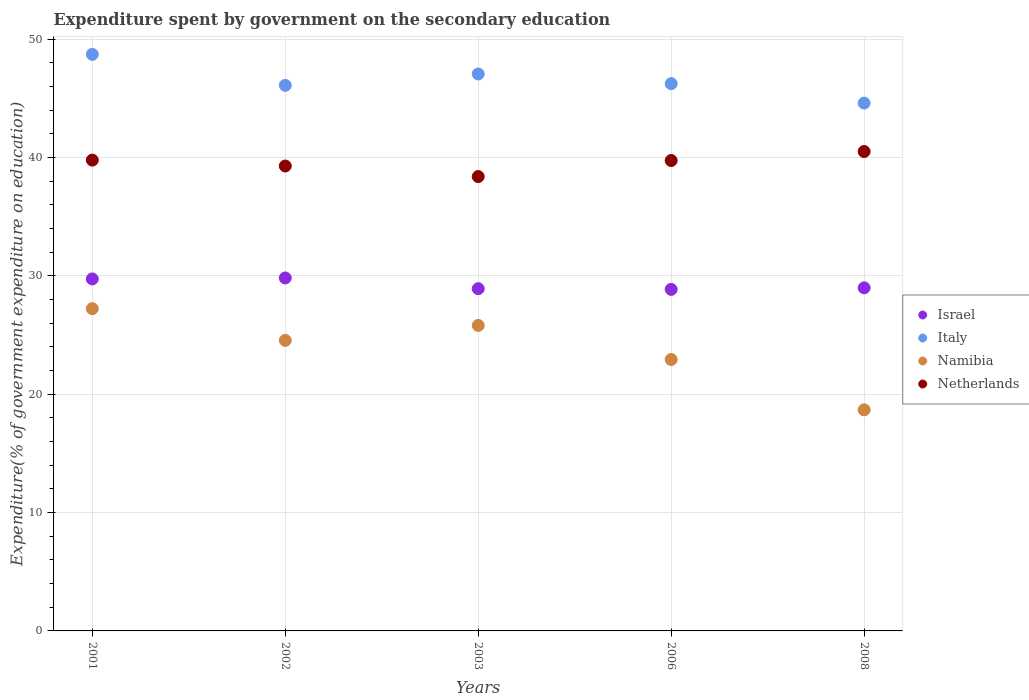How many different coloured dotlines are there?
Keep it short and to the point. 4. What is the expenditure spent by government on the secondary education in Israel in 2001?
Your answer should be compact. 29.74. Across all years, what is the maximum expenditure spent by government on the secondary education in Italy?
Your response must be concise. 48.71. Across all years, what is the minimum expenditure spent by government on the secondary education in Israel?
Provide a succinct answer. 28.85. In which year was the expenditure spent by government on the secondary education in Israel minimum?
Provide a succinct answer. 2006. What is the total expenditure spent by government on the secondary education in Namibia in the graph?
Your response must be concise. 119.19. What is the difference between the expenditure spent by government on the secondary education in Italy in 2001 and that in 2006?
Ensure brevity in your answer.  2.47. What is the difference between the expenditure spent by government on the secondary education in Israel in 2006 and the expenditure spent by government on the secondary education in Namibia in 2002?
Provide a succinct answer. 4.31. What is the average expenditure spent by government on the secondary education in Namibia per year?
Keep it short and to the point. 23.84. In the year 2008, what is the difference between the expenditure spent by government on the secondary education in Italy and expenditure spent by government on the secondary education in Namibia?
Give a very brief answer. 25.91. What is the ratio of the expenditure spent by government on the secondary education in Israel in 2002 to that in 2006?
Your response must be concise. 1.03. What is the difference between the highest and the second highest expenditure spent by government on the secondary education in Namibia?
Your response must be concise. 1.42. What is the difference between the highest and the lowest expenditure spent by government on the secondary education in Netherlands?
Keep it short and to the point. 2.12. Is it the case that in every year, the sum of the expenditure spent by government on the secondary education in Israel and expenditure spent by government on the secondary education in Netherlands  is greater than the expenditure spent by government on the secondary education in Namibia?
Your answer should be compact. Yes. How many dotlines are there?
Ensure brevity in your answer.  4. How many years are there in the graph?
Provide a succinct answer. 5. Are the values on the major ticks of Y-axis written in scientific E-notation?
Your response must be concise. No. Does the graph contain grids?
Keep it short and to the point. Yes. How many legend labels are there?
Provide a succinct answer. 4. What is the title of the graph?
Your answer should be compact. Expenditure spent by government on the secondary education. What is the label or title of the Y-axis?
Your answer should be compact. Expenditure(% of government expenditure on education). What is the Expenditure(% of government expenditure on education) in Israel in 2001?
Ensure brevity in your answer.  29.74. What is the Expenditure(% of government expenditure on education) in Italy in 2001?
Offer a very short reply. 48.71. What is the Expenditure(% of government expenditure on education) of Namibia in 2001?
Provide a succinct answer. 27.22. What is the Expenditure(% of government expenditure on education) of Netherlands in 2001?
Offer a terse response. 39.77. What is the Expenditure(% of government expenditure on education) of Israel in 2002?
Provide a succinct answer. 29.82. What is the Expenditure(% of government expenditure on education) of Italy in 2002?
Offer a terse response. 46.09. What is the Expenditure(% of government expenditure on education) of Namibia in 2002?
Your answer should be very brief. 24.55. What is the Expenditure(% of government expenditure on education) of Netherlands in 2002?
Your answer should be very brief. 39.28. What is the Expenditure(% of government expenditure on education) in Israel in 2003?
Offer a terse response. 28.91. What is the Expenditure(% of government expenditure on education) in Italy in 2003?
Provide a succinct answer. 47.05. What is the Expenditure(% of government expenditure on education) of Namibia in 2003?
Provide a succinct answer. 25.81. What is the Expenditure(% of government expenditure on education) in Netherlands in 2003?
Give a very brief answer. 38.38. What is the Expenditure(% of government expenditure on education) of Israel in 2006?
Provide a succinct answer. 28.85. What is the Expenditure(% of government expenditure on education) in Italy in 2006?
Provide a short and direct response. 46.24. What is the Expenditure(% of government expenditure on education) in Namibia in 2006?
Keep it short and to the point. 22.93. What is the Expenditure(% of government expenditure on education) of Netherlands in 2006?
Offer a terse response. 39.74. What is the Expenditure(% of government expenditure on education) of Israel in 2008?
Give a very brief answer. 28.99. What is the Expenditure(% of government expenditure on education) in Italy in 2008?
Ensure brevity in your answer.  44.59. What is the Expenditure(% of government expenditure on education) in Namibia in 2008?
Your answer should be compact. 18.68. What is the Expenditure(% of government expenditure on education) in Netherlands in 2008?
Provide a short and direct response. 40.5. Across all years, what is the maximum Expenditure(% of government expenditure on education) in Israel?
Offer a very short reply. 29.82. Across all years, what is the maximum Expenditure(% of government expenditure on education) of Italy?
Your response must be concise. 48.71. Across all years, what is the maximum Expenditure(% of government expenditure on education) of Namibia?
Provide a succinct answer. 27.22. Across all years, what is the maximum Expenditure(% of government expenditure on education) of Netherlands?
Provide a short and direct response. 40.5. Across all years, what is the minimum Expenditure(% of government expenditure on education) in Israel?
Keep it short and to the point. 28.85. Across all years, what is the minimum Expenditure(% of government expenditure on education) in Italy?
Your answer should be very brief. 44.59. Across all years, what is the minimum Expenditure(% of government expenditure on education) in Namibia?
Keep it short and to the point. 18.68. Across all years, what is the minimum Expenditure(% of government expenditure on education) of Netherlands?
Offer a terse response. 38.38. What is the total Expenditure(% of government expenditure on education) of Israel in the graph?
Offer a very short reply. 146.31. What is the total Expenditure(% of government expenditure on education) of Italy in the graph?
Your response must be concise. 232.68. What is the total Expenditure(% of government expenditure on education) of Namibia in the graph?
Offer a terse response. 119.19. What is the total Expenditure(% of government expenditure on education) of Netherlands in the graph?
Provide a succinct answer. 197.68. What is the difference between the Expenditure(% of government expenditure on education) in Israel in 2001 and that in 2002?
Provide a succinct answer. -0.08. What is the difference between the Expenditure(% of government expenditure on education) in Italy in 2001 and that in 2002?
Offer a very short reply. 2.62. What is the difference between the Expenditure(% of government expenditure on education) in Namibia in 2001 and that in 2002?
Your answer should be compact. 2.68. What is the difference between the Expenditure(% of government expenditure on education) in Netherlands in 2001 and that in 2002?
Make the answer very short. 0.5. What is the difference between the Expenditure(% of government expenditure on education) of Israel in 2001 and that in 2003?
Your answer should be very brief. 0.82. What is the difference between the Expenditure(% of government expenditure on education) of Italy in 2001 and that in 2003?
Give a very brief answer. 1.66. What is the difference between the Expenditure(% of government expenditure on education) of Namibia in 2001 and that in 2003?
Your answer should be very brief. 1.42. What is the difference between the Expenditure(% of government expenditure on education) of Netherlands in 2001 and that in 2003?
Your answer should be very brief. 1.39. What is the difference between the Expenditure(% of government expenditure on education) of Israel in 2001 and that in 2006?
Keep it short and to the point. 0.88. What is the difference between the Expenditure(% of government expenditure on education) of Italy in 2001 and that in 2006?
Make the answer very short. 2.47. What is the difference between the Expenditure(% of government expenditure on education) of Namibia in 2001 and that in 2006?
Keep it short and to the point. 4.29. What is the difference between the Expenditure(% of government expenditure on education) of Netherlands in 2001 and that in 2006?
Your answer should be compact. 0.03. What is the difference between the Expenditure(% of government expenditure on education) in Israel in 2001 and that in 2008?
Make the answer very short. 0.75. What is the difference between the Expenditure(% of government expenditure on education) in Italy in 2001 and that in 2008?
Your answer should be compact. 4.12. What is the difference between the Expenditure(% of government expenditure on education) in Namibia in 2001 and that in 2008?
Provide a short and direct response. 8.55. What is the difference between the Expenditure(% of government expenditure on education) of Netherlands in 2001 and that in 2008?
Your answer should be very brief. -0.73. What is the difference between the Expenditure(% of government expenditure on education) in Israel in 2002 and that in 2003?
Give a very brief answer. 0.91. What is the difference between the Expenditure(% of government expenditure on education) in Italy in 2002 and that in 2003?
Your answer should be very brief. -0.96. What is the difference between the Expenditure(% of government expenditure on education) in Namibia in 2002 and that in 2003?
Give a very brief answer. -1.26. What is the difference between the Expenditure(% of government expenditure on education) in Netherlands in 2002 and that in 2003?
Provide a short and direct response. 0.89. What is the difference between the Expenditure(% of government expenditure on education) of Israel in 2002 and that in 2006?
Provide a short and direct response. 0.96. What is the difference between the Expenditure(% of government expenditure on education) in Italy in 2002 and that in 2006?
Provide a succinct answer. -0.14. What is the difference between the Expenditure(% of government expenditure on education) of Namibia in 2002 and that in 2006?
Make the answer very short. 1.62. What is the difference between the Expenditure(% of government expenditure on education) in Netherlands in 2002 and that in 2006?
Your answer should be compact. -0.46. What is the difference between the Expenditure(% of government expenditure on education) of Israel in 2002 and that in 2008?
Offer a very short reply. 0.83. What is the difference between the Expenditure(% of government expenditure on education) in Italy in 2002 and that in 2008?
Make the answer very short. 1.5. What is the difference between the Expenditure(% of government expenditure on education) of Namibia in 2002 and that in 2008?
Make the answer very short. 5.87. What is the difference between the Expenditure(% of government expenditure on education) of Netherlands in 2002 and that in 2008?
Give a very brief answer. -1.22. What is the difference between the Expenditure(% of government expenditure on education) in Israel in 2003 and that in 2006?
Your answer should be compact. 0.06. What is the difference between the Expenditure(% of government expenditure on education) of Italy in 2003 and that in 2006?
Make the answer very short. 0.82. What is the difference between the Expenditure(% of government expenditure on education) in Namibia in 2003 and that in 2006?
Keep it short and to the point. 2.88. What is the difference between the Expenditure(% of government expenditure on education) of Netherlands in 2003 and that in 2006?
Keep it short and to the point. -1.36. What is the difference between the Expenditure(% of government expenditure on education) of Israel in 2003 and that in 2008?
Your response must be concise. -0.07. What is the difference between the Expenditure(% of government expenditure on education) of Italy in 2003 and that in 2008?
Make the answer very short. 2.46. What is the difference between the Expenditure(% of government expenditure on education) in Namibia in 2003 and that in 2008?
Provide a short and direct response. 7.13. What is the difference between the Expenditure(% of government expenditure on education) in Netherlands in 2003 and that in 2008?
Keep it short and to the point. -2.12. What is the difference between the Expenditure(% of government expenditure on education) of Israel in 2006 and that in 2008?
Provide a succinct answer. -0.13. What is the difference between the Expenditure(% of government expenditure on education) of Italy in 2006 and that in 2008?
Your answer should be compact. 1.64. What is the difference between the Expenditure(% of government expenditure on education) of Namibia in 2006 and that in 2008?
Ensure brevity in your answer.  4.25. What is the difference between the Expenditure(% of government expenditure on education) in Netherlands in 2006 and that in 2008?
Provide a short and direct response. -0.76. What is the difference between the Expenditure(% of government expenditure on education) of Israel in 2001 and the Expenditure(% of government expenditure on education) of Italy in 2002?
Keep it short and to the point. -16.35. What is the difference between the Expenditure(% of government expenditure on education) in Israel in 2001 and the Expenditure(% of government expenditure on education) in Namibia in 2002?
Your answer should be very brief. 5.19. What is the difference between the Expenditure(% of government expenditure on education) in Israel in 2001 and the Expenditure(% of government expenditure on education) in Netherlands in 2002?
Make the answer very short. -9.54. What is the difference between the Expenditure(% of government expenditure on education) of Italy in 2001 and the Expenditure(% of government expenditure on education) of Namibia in 2002?
Offer a very short reply. 24.16. What is the difference between the Expenditure(% of government expenditure on education) of Italy in 2001 and the Expenditure(% of government expenditure on education) of Netherlands in 2002?
Provide a short and direct response. 9.43. What is the difference between the Expenditure(% of government expenditure on education) of Namibia in 2001 and the Expenditure(% of government expenditure on education) of Netherlands in 2002?
Offer a very short reply. -12.05. What is the difference between the Expenditure(% of government expenditure on education) in Israel in 2001 and the Expenditure(% of government expenditure on education) in Italy in 2003?
Ensure brevity in your answer.  -17.32. What is the difference between the Expenditure(% of government expenditure on education) of Israel in 2001 and the Expenditure(% of government expenditure on education) of Namibia in 2003?
Provide a succinct answer. 3.93. What is the difference between the Expenditure(% of government expenditure on education) of Israel in 2001 and the Expenditure(% of government expenditure on education) of Netherlands in 2003?
Your answer should be very brief. -8.65. What is the difference between the Expenditure(% of government expenditure on education) of Italy in 2001 and the Expenditure(% of government expenditure on education) of Namibia in 2003?
Give a very brief answer. 22.9. What is the difference between the Expenditure(% of government expenditure on education) of Italy in 2001 and the Expenditure(% of government expenditure on education) of Netherlands in 2003?
Make the answer very short. 10.33. What is the difference between the Expenditure(% of government expenditure on education) of Namibia in 2001 and the Expenditure(% of government expenditure on education) of Netherlands in 2003?
Provide a succinct answer. -11.16. What is the difference between the Expenditure(% of government expenditure on education) of Israel in 2001 and the Expenditure(% of government expenditure on education) of Italy in 2006?
Offer a terse response. -16.5. What is the difference between the Expenditure(% of government expenditure on education) in Israel in 2001 and the Expenditure(% of government expenditure on education) in Namibia in 2006?
Your answer should be compact. 6.81. What is the difference between the Expenditure(% of government expenditure on education) in Israel in 2001 and the Expenditure(% of government expenditure on education) in Netherlands in 2006?
Keep it short and to the point. -10. What is the difference between the Expenditure(% of government expenditure on education) in Italy in 2001 and the Expenditure(% of government expenditure on education) in Namibia in 2006?
Your response must be concise. 25.78. What is the difference between the Expenditure(% of government expenditure on education) in Italy in 2001 and the Expenditure(% of government expenditure on education) in Netherlands in 2006?
Your answer should be very brief. 8.97. What is the difference between the Expenditure(% of government expenditure on education) of Namibia in 2001 and the Expenditure(% of government expenditure on education) of Netherlands in 2006?
Keep it short and to the point. -12.52. What is the difference between the Expenditure(% of government expenditure on education) of Israel in 2001 and the Expenditure(% of government expenditure on education) of Italy in 2008?
Provide a short and direct response. -14.86. What is the difference between the Expenditure(% of government expenditure on education) in Israel in 2001 and the Expenditure(% of government expenditure on education) in Namibia in 2008?
Offer a very short reply. 11.06. What is the difference between the Expenditure(% of government expenditure on education) in Israel in 2001 and the Expenditure(% of government expenditure on education) in Netherlands in 2008?
Your response must be concise. -10.76. What is the difference between the Expenditure(% of government expenditure on education) of Italy in 2001 and the Expenditure(% of government expenditure on education) of Namibia in 2008?
Your response must be concise. 30.03. What is the difference between the Expenditure(% of government expenditure on education) of Italy in 2001 and the Expenditure(% of government expenditure on education) of Netherlands in 2008?
Give a very brief answer. 8.21. What is the difference between the Expenditure(% of government expenditure on education) in Namibia in 2001 and the Expenditure(% of government expenditure on education) in Netherlands in 2008?
Provide a short and direct response. -13.28. What is the difference between the Expenditure(% of government expenditure on education) of Israel in 2002 and the Expenditure(% of government expenditure on education) of Italy in 2003?
Keep it short and to the point. -17.23. What is the difference between the Expenditure(% of government expenditure on education) in Israel in 2002 and the Expenditure(% of government expenditure on education) in Namibia in 2003?
Your answer should be compact. 4.01. What is the difference between the Expenditure(% of government expenditure on education) of Israel in 2002 and the Expenditure(% of government expenditure on education) of Netherlands in 2003?
Give a very brief answer. -8.57. What is the difference between the Expenditure(% of government expenditure on education) in Italy in 2002 and the Expenditure(% of government expenditure on education) in Namibia in 2003?
Provide a succinct answer. 20.28. What is the difference between the Expenditure(% of government expenditure on education) in Italy in 2002 and the Expenditure(% of government expenditure on education) in Netherlands in 2003?
Provide a short and direct response. 7.71. What is the difference between the Expenditure(% of government expenditure on education) in Namibia in 2002 and the Expenditure(% of government expenditure on education) in Netherlands in 2003?
Your answer should be compact. -13.84. What is the difference between the Expenditure(% of government expenditure on education) in Israel in 2002 and the Expenditure(% of government expenditure on education) in Italy in 2006?
Your answer should be compact. -16.42. What is the difference between the Expenditure(% of government expenditure on education) in Israel in 2002 and the Expenditure(% of government expenditure on education) in Namibia in 2006?
Provide a succinct answer. 6.89. What is the difference between the Expenditure(% of government expenditure on education) of Israel in 2002 and the Expenditure(% of government expenditure on education) of Netherlands in 2006?
Provide a succinct answer. -9.92. What is the difference between the Expenditure(% of government expenditure on education) in Italy in 2002 and the Expenditure(% of government expenditure on education) in Namibia in 2006?
Keep it short and to the point. 23.16. What is the difference between the Expenditure(% of government expenditure on education) in Italy in 2002 and the Expenditure(% of government expenditure on education) in Netherlands in 2006?
Give a very brief answer. 6.35. What is the difference between the Expenditure(% of government expenditure on education) of Namibia in 2002 and the Expenditure(% of government expenditure on education) of Netherlands in 2006?
Your response must be concise. -15.19. What is the difference between the Expenditure(% of government expenditure on education) of Israel in 2002 and the Expenditure(% of government expenditure on education) of Italy in 2008?
Offer a very short reply. -14.77. What is the difference between the Expenditure(% of government expenditure on education) in Israel in 2002 and the Expenditure(% of government expenditure on education) in Namibia in 2008?
Keep it short and to the point. 11.14. What is the difference between the Expenditure(% of government expenditure on education) of Israel in 2002 and the Expenditure(% of government expenditure on education) of Netherlands in 2008?
Your answer should be very brief. -10.68. What is the difference between the Expenditure(% of government expenditure on education) in Italy in 2002 and the Expenditure(% of government expenditure on education) in Namibia in 2008?
Keep it short and to the point. 27.41. What is the difference between the Expenditure(% of government expenditure on education) of Italy in 2002 and the Expenditure(% of government expenditure on education) of Netherlands in 2008?
Make the answer very short. 5.59. What is the difference between the Expenditure(% of government expenditure on education) of Namibia in 2002 and the Expenditure(% of government expenditure on education) of Netherlands in 2008?
Your answer should be very brief. -15.95. What is the difference between the Expenditure(% of government expenditure on education) of Israel in 2003 and the Expenditure(% of government expenditure on education) of Italy in 2006?
Make the answer very short. -17.32. What is the difference between the Expenditure(% of government expenditure on education) in Israel in 2003 and the Expenditure(% of government expenditure on education) in Namibia in 2006?
Your answer should be compact. 5.98. What is the difference between the Expenditure(% of government expenditure on education) in Israel in 2003 and the Expenditure(% of government expenditure on education) in Netherlands in 2006?
Keep it short and to the point. -10.83. What is the difference between the Expenditure(% of government expenditure on education) in Italy in 2003 and the Expenditure(% of government expenditure on education) in Namibia in 2006?
Ensure brevity in your answer.  24.12. What is the difference between the Expenditure(% of government expenditure on education) in Italy in 2003 and the Expenditure(% of government expenditure on education) in Netherlands in 2006?
Ensure brevity in your answer.  7.31. What is the difference between the Expenditure(% of government expenditure on education) in Namibia in 2003 and the Expenditure(% of government expenditure on education) in Netherlands in 2006?
Ensure brevity in your answer.  -13.93. What is the difference between the Expenditure(% of government expenditure on education) of Israel in 2003 and the Expenditure(% of government expenditure on education) of Italy in 2008?
Offer a very short reply. -15.68. What is the difference between the Expenditure(% of government expenditure on education) of Israel in 2003 and the Expenditure(% of government expenditure on education) of Namibia in 2008?
Offer a very short reply. 10.23. What is the difference between the Expenditure(% of government expenditure on education) of Israel in 2003 and the Expenditure(% of government expenditure on education) of Netherlands in 2008?
Your answer should be compact. -11.59. What is the difference between the Expenditure(% of government expenditure on education) in Italy in 2003 and the Expenditure(% of government expenditure on education) in Namibia in 2008?
Offer a terse response. 28.37. What is the difference between the Expenditure(% of government expenditure on education) of Italy in 2003 and the Expenditure(% of government expenditure on education) of Netherlands in 2008?
Ensure brevity in your answer.  6.55. What is the difference between the Expenditure(% of government expenditure on education) of Namibia in 2003 and the Expenditure(% of government expenditure on education) of Netherlands in 2008?
Ensure brevity in your answer.  -14.69. What is the difference between the Expenditure(% of government expenditure on education) in Israel in 2006 and the Expenditure(% of government expenditure on education) in Italy in 2008?
Ensure brevity in your answer.  -15.74. What is the difference between the Expenditure(% of government expenditure on education) in Israel in 2006 and the Expenditure(% of government expenditure on education) in Namibia in 2008?
Your response must be concise. 10.18. What is the difference between the Expenditure(% of government expenditure on education) of Israel in 2006 and the Expenditure(% of government expenditure on education) of Netherlands in 2008?
Offer a terse response. -11.65. What is the difference between the Expenditure(% of government expenditure on education) of Italy in 2006 and the Expenditure(% of government expenditure on education) of Namibia in 2008?
Offer a terse response. 27.56. What is the difference between the Expenditure(% of government expenditure on education) in Italy in 2006 and the Expenditure(% of government expenditure on education) in Netherlands in 2008?
Provide a short and direct response. 5.74. What is the difference between the Expenditure(% of government expenditure on education) in Namibia in 2006 and the Expenditure(% of government expenditure on education) in Netherlands in 2008?
Keep it short and to the point. -17.57. What is the average Expenditure(% of government expenditure on education) in Israel per year?
Keep it short and to the point. 29.26. What is the average Expenditure(% of government expenditure on education) of Italy per year?
Offer a very short reply. 46.54. What is the average Expenditure(% of government expenditure on education) in Namibia per year?
Provide a succinct answer. 23.84. What is the average Expenditure(% of government expenditure on education) of Netherlands per year?
Your response must be concise. 39.53. In the year 2001, what is the difference between the Expenditure(% of government expenditure on education) of Israel and Expenditure(% of government expenditure on education) of Italy?
Offer a very short reply. -18.97. In the year 2001, what is the difference between the Expenditure(% of government expenditure on education) of Israel and Expenditure(% of government expenditure on education) of Namibia?
Your answer should be compact. 2.51. In the year 2001, what is the difference between the Expenditure(% of government expenditure on education) of Israel and Expenditure(% of government expenditure on education) of Netherlands?
Provide a succinct answer. -10.04. In the year 2001, what is the difference between the Expenditure(% of government expenditure on education) in Italy and Expenditure(% of government expenditure on education) in Namibia?
Provide a succinct answer. 21.49. In the year 2001, what is the difference between the Expenditure(% of government expenditure on education) of Italy and Expenditure(% of government expenditure on education) of Netherlands?
Offer a terse response. 8.94. In the year 2001, what is the difference between the Expenditure(% of government expenditure on education) of Namibia and Expenditure(% of government expenditure on education) of Netherlands?
Provide a succinct answer. -12.55. In the year 2002, what is the difference between the Expenditure(% of government expenditure on education) of Israel and Expenditure(% of government expenditure on education) of Italy?
Your response must be concise. -16.27. In the year 2002, what is the difference between the Expenditure(% of government expenditure on education) in Israel and Expenditure(% of government expenditure on education) in Namibia?
Your response must be concise. 5.27. In the year 2002, what is the difference between the Expenditure(% of government expenditure on education) of Israel and Expenditure(% of government expenditure on education) of Netherlands?
Offer a very short reply. -9.46. In the year 2002, what is the difference between the Expenditure(% of government expenditure on education) of Italy and Expenditure(% of government expenditure on education) of Namibia?
Ensure brevity in your answer.  21.54. In the year 2002, what is the difference between the Expenditure(% of government expenditure on education) in Italy and Expenditure(% of government expenditure on education) in Netherlands?
Your answer should be compact. 6.81. In the year 2002, what is the difference between the Expenditure(% of government expenditure on education) of Namibia and Expenditure(% of government expenditure on education) of Netherlands?
Offer a very short reply. -14.73. In the year 2003, what is the difference between the Expenditure(% of government expenditure on education) of Israel and Expenditure(% of government expenditure on education) of Italy?
Provide a succinct answer. -18.14. In the year 2003, what is the difference between the Expenditure(% of government expenditure on education) in Israel and Expenditure(% of government expenditure on education) in Namibia?
Keep it short and to the point. 3.1. In the year 2003, what is the difference between the Expenditure(% of government expenditure on education) of Israel and Expenditure(% of government expenditure on education) of Netherlands?
Provide a short and direct response. -9.47. In the year 2003, what is the difference between the Expenditure(% of government expenditure on education) in Italy and Expenditure(% of government expenditure on education) in Namibia?
Provide a succinct answer. 21.24. In the year 2003, what is the difference between the Expenditure(% of government expenditure on education) in Italy and Expenditure(% of government expenditure on education) in Netherlands?
Your answer should be compact. 8.67. In the year 2003, what is the difference between the Expenditure(% of government expenditure on education) in Namibia and Expenditure(% of government expenditure on education) in Netherlands?
Your answer should be very brief. -12.58. In the year 2006, what is the difference between the Expenditure(% of government expenditure on education) in Israel and Expenditure(% of government expenditure on education) in Italy?
Provide a succinct answer. -17.38. In the year 2006, what is the difference between the Expenditure(% of government expenditure on education) of Israel and Expenditure(% of government expenditure on education) of Namibia?
Offer a terse response. 5.92. In the year 2006, what is the difference between the Expenditure(% of government expenditure on education) in Israel and Expenditure(% of government expenditure on education) in Netherlands?
Your response must be concise. -10.89. In the year 2006, what is the difference between the Expenditure(% of government expenditure on education) of Italy and Expenditure(% of government expenditure on education) of Namibia?
Provide a short and direct response. 23.31. In the year 2006, what is the difference between the Expenditure(% of government expenditure on education) in Italy and Expenditure(% of government expenditure on education) in Netherlands?
Provide a short and direct response. 6.5. In the year 2006, what is the difference between the Expenditure(% of government expenditure on education) in Namibia and Expenditure(% of government expenditure on education) in Netherlands?
Your response must be concise. -16.81. In the year 2008, what is the difference between the Expenditure(% of government expenditure on education) in Israel and Expenditure(% of government expenditure on education) in Italy?
Make the answer very short. -15.61. In the year 2008, what is the difference between the Expenditure(% of government expenditure on education) in Israel and Expenditure(% of government expenditure on education) in Namibia?
Make the answer very short. 10.31. In the year 2008, what is the difference between the Expenditure(% of government expenditure on education) of Israel and Expenditure(% of government expenditure on education) of Netherlands?
Keep it short and to the point. -11.51. In the year 2008, what is the difference between the Expenditure(% of government expenditure on education) of Italy and Expenditure(% of government expenditure on education) of Namibia?
Provide a succinct answer. 25.91. In the year 2008, what is the difference between the Expenditure(% of government expenditure on education) of Italy and Expenditure(% of government expenditure on education) of Netherlands?
Offer a terse response. 4.09. In the year 2008, what is the difference between the Expenditure(% of government expenditure on education) of Namibia and Expenditure(% of government expenditure on education) of Netherlands?
Offer a very short reply. -21.82. What is the ratio of the Expenditure(% of government expenditure on education) in Italy in 2001 to that in 2002?
Offer a very short reply. 1.06. What is the ratio of the Expenditure(% of government expenditure on education) in Namibia in 2001 to that in 2002?
Your answer should be compact. 1.11. What is the ratio of the Expenditure(% of government expenditure on education) of Netherlands in 2001 to that in 2002?
Offer a terse response. 1.01. What is the ratio of the Expenditure(% of government expenditure on education) in Israel in 2001 to that in 2003?
Keep it short and to the point. 1.03. What is the ratio of the Expenditure(% of government expenditure on education) of Italy in 2001 to that in 2003?
Keep it short and to the point. 1.04. What is the ratio of the Expenditure(% of government expenditure on education) of Namibia in 2001 to that in 2003?
Your answer should be very brief. 1.05. What is the ratio of the Expenditure(% of government expenditure on education) in Netherlands in 2001 to that in 2003?
Ensure brevity in your answer.  1.04. What is the ratio of the Expenditure(% of government expenditure on education) in Israel in 2001 to that in 2006?
Your answer should be compact. 1.03. What is the ratio of the Expenditure(% of government expenditure on education) in Italy in 2001 to that in 2006?
Provide a succinct answer. 1.05. What is the ratio of the Expenditure(% of government expenditure on education) of Namibia in 2001 to that in 2006?
Your answer should be compact. 1.19. What is the ratio of the Expenditure(% of government expenditure on education) of Israel in 2001 to that in 2008?
Your response must be concise. 1.03. What is the ratio of the Expenditure(% of government expenditure on education) of Italy in 2001 to that in 2008?
Ensure brevity in your answer.  1.09. What is the ratio of the Expenditure(% of government expenditure on education) of Namibia in 2001 to that in 2008?
Offer a terse response. 1.46. What is the ratio of the Expenditure(% of government expenditure on education) of Netherlands in 2001 to that in 2008?
Offer a terse response. 0.98. What is the ratio of the Expenditure(% of government expenditure on education) of Israel in 2002 to that in 2003?
Offer a terse response. 1.03. What is the ratio of the Expenditure(% of government expenditure on education) of Italy in 2002 to that in 2003?
Your answer should be compact. 0.98. What is the ratio of the Expenditure(% of government expenditure on education) of Namibia in 2002 to that in 2003?
Offer a terse response. 0.95. What is the ratio of the Expenditure(% of government expenditure on education) of Netherlands in 2002 to that in 2003?
Your answer should be compact. 1.02. What is the ratio of the Expenditure(% of government expenditure on education) in Israel in 2002 to that in 2006?
Offer a terse response. 1.03. What is the ratio of the Expenditure(% of government expenditure on education) of Namibia in 2002 to that in 2006?
Provide a short and direct response. 1.07. What is the ratio of the Expenditure(% of government expenditure on education) of Netherlands in 2002 to that in 2006?
Keep it short and to the point. 0.99. What is the ratio of the Expenditure(% of government expenditure on education) in Israel in 2002 to that in 2008?
Your answer should be compact. 1.03. What is the ratio of the Expenditure(% of government expenditure on education) of Italy in 2002 to that in 2008?
Keep it short and to the point. 1.03. What is the ratio of the Expenditure(% of government expenditure on education) of Namibia in 2002 to that in 2008?
Make the answer very short. 1.31. What is the ratio of the Expenditure(% of government expenditure on education) of Netherlands in 2002 to that in 2008?
Offer a very short reply. 0.97. What is the ratio of the Expenditure(% of government expenditure on education) of Israel in 2003 to that in 2006?
Give a very brief answer. 1. What is the ratio of the Expenditure(% of government expenditure on education) in Italy in 2003 to that in 2006?
Make the answer very short. 1.02. What is the ratio of the Expenditure(% of government expenditure on education) of Namibia in 2003 to that in 2006?
Provide a short and direct response. 1.13. What is the ratio of the Expenditure(% of government expenditure on education) of Netherlands in 2003 to that in 2006?
Keep it short and to the point. 0.97. What is the ratio of the Expenditure(% of government expenditure on education) in Italy in 2003 to that in 2008?
Provide a succinct answer. 1.06. What is the ratio of the Expenditure(% of government expenditure on education) of Namibia in 2003 to that in 2008?
Your response must be concise. 1.38. What is the ratio of the Expenditure(% of government expenditure on education) in Netherlands in 2003 to that in 2008?
Make the answer very short. 0.95. What is the ratio of the Expenditure(% of government expenditure on education) in Israel in 2006 to that in 2008?
Make the answer very short. 1. What is the ratio of the Expenditure(% of government expenditure on education) of Italy in 2006 to that in 2008?
Make the answer very short. 1.04. What is the ratio of the Expenditure(% of government expenditure on education) of Namibia in 2006 to that in 2008?
Keep it short and to the point. 1.23. What is the ratio of the Expenditure(% of government expenditure on education) in Netherlands in 2006 to that in 2008?
Your answer should be very brief. 0.98. What is the difference between the highest and the second highest Expenditure(% of government expenditure on education) in Israel?
Keep it short and to the point. 0.08. What is the difference between the highest and the second highest Expenditure(% of government expenditure on education) in Italy?
Offer a terse response. 1.66. What is the difference between the highest and the second highest Expenditure(% of government expenditure on education) of Namibia?
Keep it short and to the point. 1.42. What is the difference between the highest and the second highest Expenditure(% of government expenditure on education) in Netherlands?
Make the answer very short. 0.73. What is the difference between the highest and the lowest Expenditure(% of government expenditure on education) in Israel?
Your response must be concise. 0.96. What is the difference between the highest and the lowest Expenditure(% of government expenditure on education) in Italy?
Keep it short and to the point. 4.12. What is the difference between the highest and the lowest Expenditure(% of government expenditure on education) of Namibia?
Your answer should be very brief. 8.55. What is the difference between the highest and the lowest Expenditure(% of government expenditure on education) of Netherlands?
Provide a succinct answer. 2.12. 